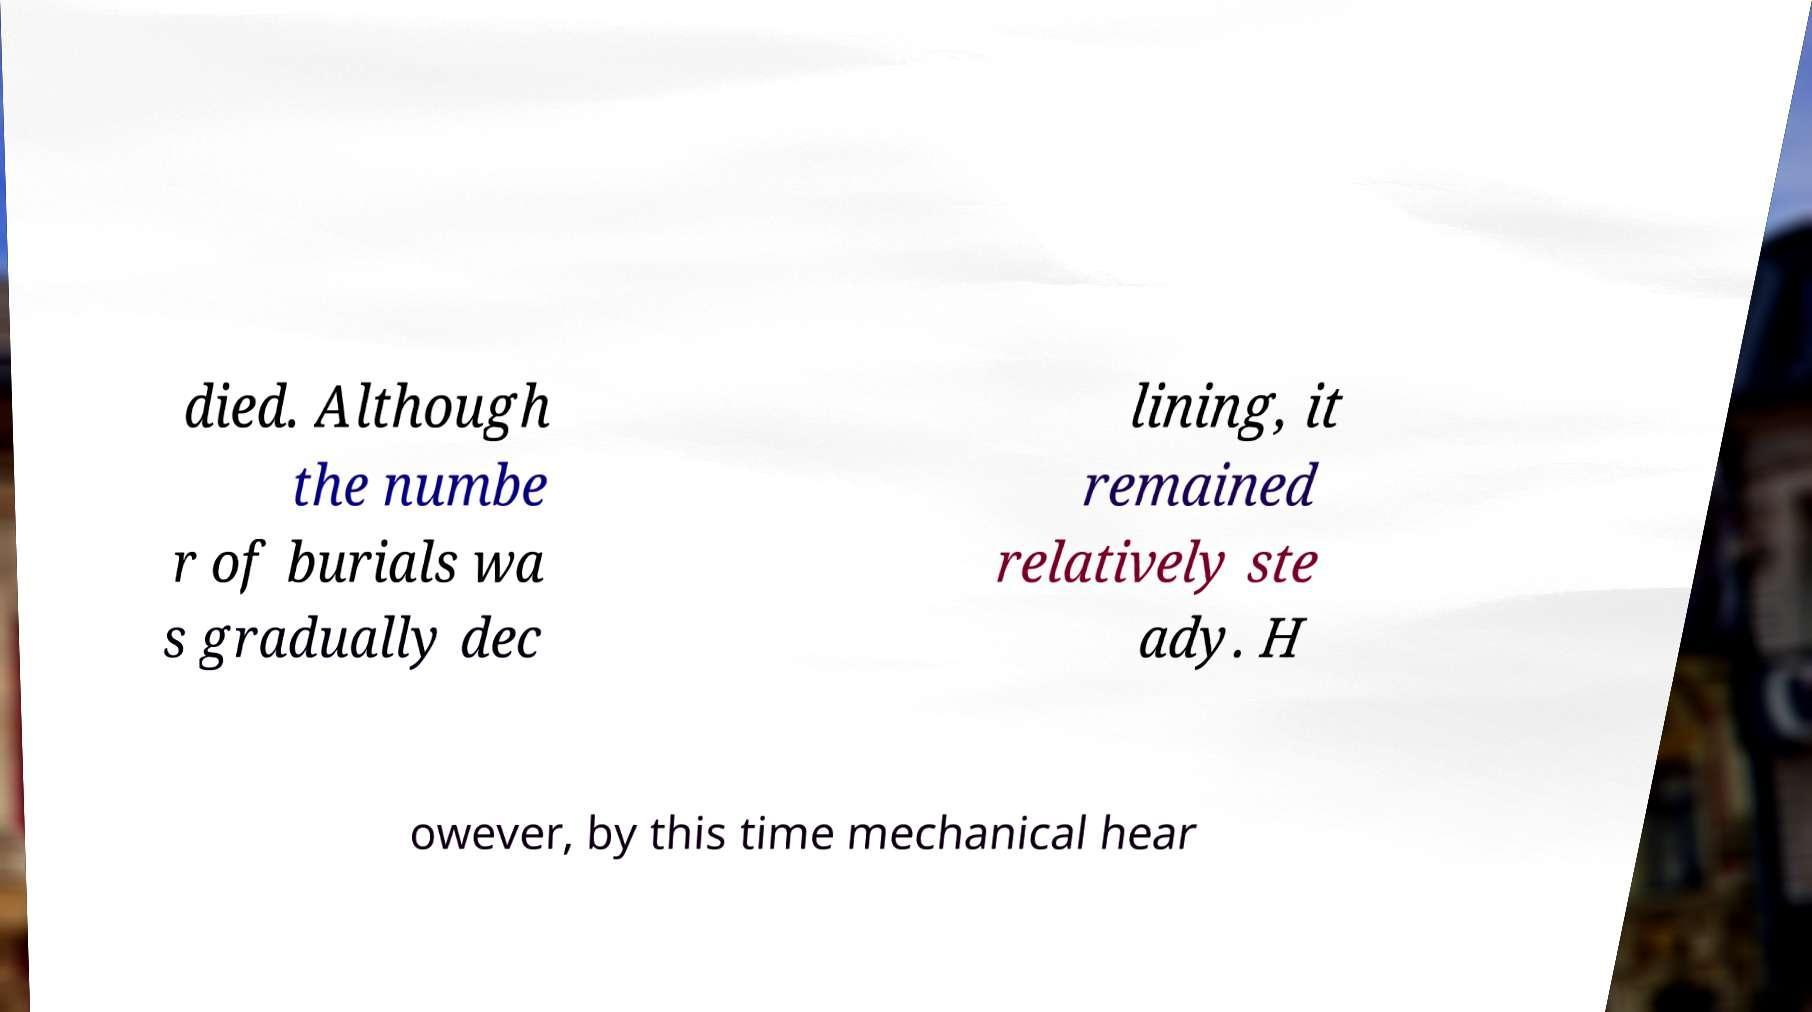Please identify and transcribe the text found in this image. died. Although the numbe r of burials wa s gradually dec lining, it remained relatively ste ady. H owever, by this time mechanical hear 